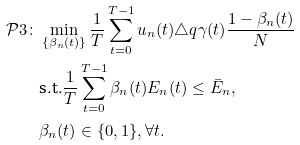<formula> <loc_0><loc_0><loc_500><loc_500>\mathcal { P } 3 \colon & \min _ { \left \{ \beta _ { n } ( t ) \right \} } \frac { 1 } { T } \sum _ { t = 0 } ^ { T - 1 } u _ { n } ( t ) \triangle q \gamma ( t ) \frac { 1 - \beta _ { n } ( t ) } { N } \\ & \text {s.t.} \frac { 1 } { T } \sum _ { t = 0 } ^ { T - 1 } \beta _ { n } ( t ) E _ { n } ( t ) \leq \bar { E } _ { n } , \\ & \beta _ { n } ( t ) \in \{ 0 , 1 \} , \forall t .</formula> 